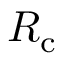<formula> <loc_0><loc_0><loc_500><loc_500>R _ { c }</formula> 